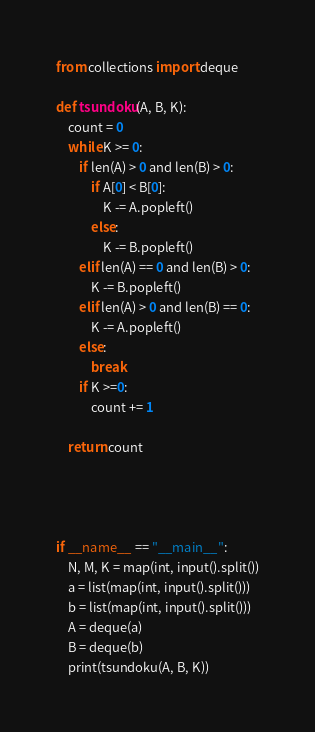Convert code to text. <code><loc_0><loc_0><loc_500><loc_500><_Python_>from collections import deque

def tsundoku(A, B, K):
    count = 0
    while K >= 0:
        if len(A) > 0 and len(B) > 0:
            if A[0] < B[0]:
                K -= A.popleft()
            else:
                K -= B.popleft()
        elif len(A) == 0 and len(B) > 0:
            K -= B.popleft()
        elif len(A) > 0 and len(B) == 0:
            K -= A.popleft()
        else:
            break
        if K >=0:
            count += 1

    return count




if __name__ == "__main__":
    N, M, K = map(int, input().split())
    a = list(map(int, input().split()))
    b = list(map(int, input().split()))
    A = deque(a)
    B = deque(b)
    print(tsundoku(A, B, K))</code> 